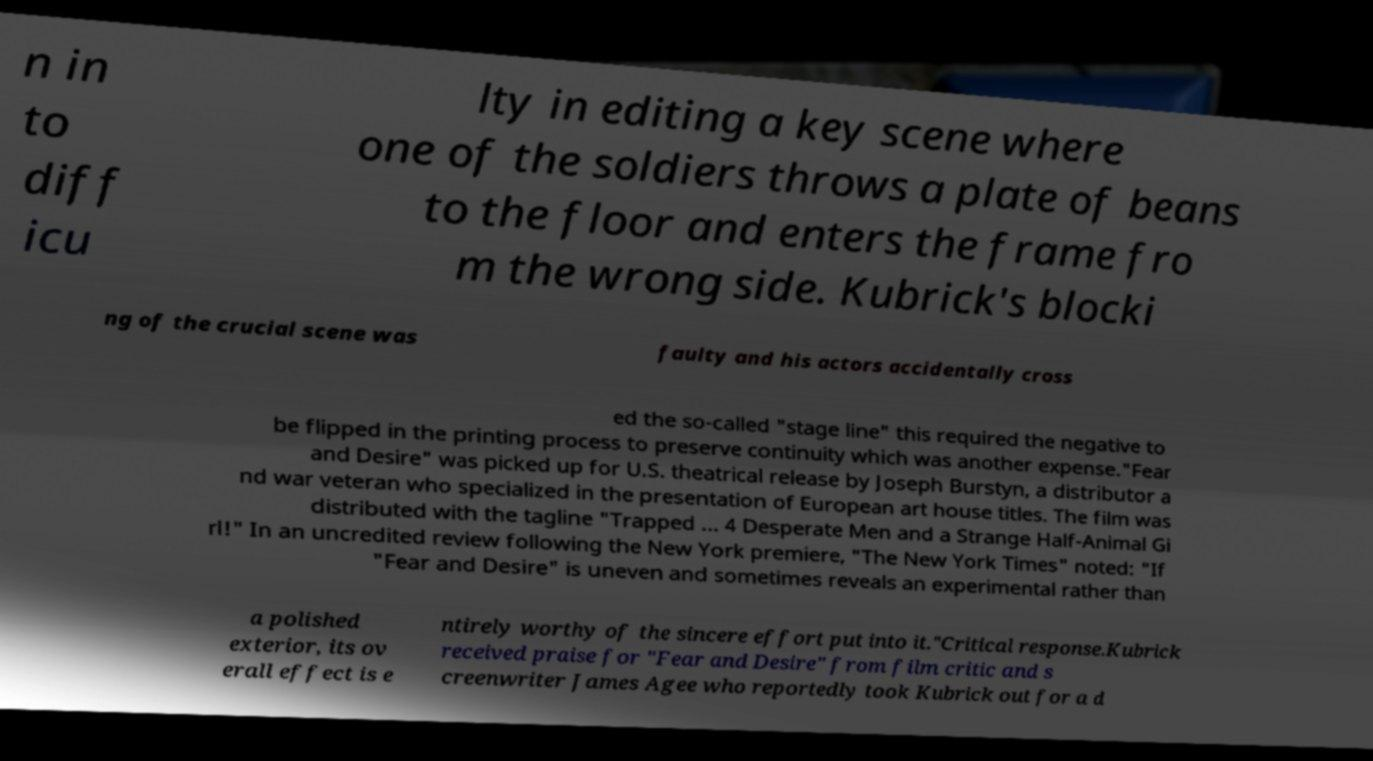Could you assist in decoding the text presented in this image and type it out clearly? n in to diff icu lty in editing a key scene where one of the soldiers throws a plate of beans to the floor and enters the frame fro m the wrong side. Kubrick's blocki ng of the crucial scene was faulty and his actors accidentally cross ed the so-called "stage line" this required the negative to be flipped in the printing process to preserve continuity which was another expense."Fear and Desire" was picked up for U.S. theatrical release by Joseph Burstyn, a distributor a nd war veteran who specialized in the presentation of European art house titles. The film was distributed with the tagline "Trapped ... 4 Desperate Men and a Strange Half-Animal Gi rl!" In an uncredited review following the New York premiere, "The New York Times" noted: "If "Fear and Desire" is uneven and sometimes reveals an experimental rather than a polished exterior, its ov erall effect is e ntirely worthy of the sincere effort put into it."Critical response.Kubrick received praise for "Fear and Desire" from film critic and s creenwriter James Agee who reportedly took Kubrick out for a d 